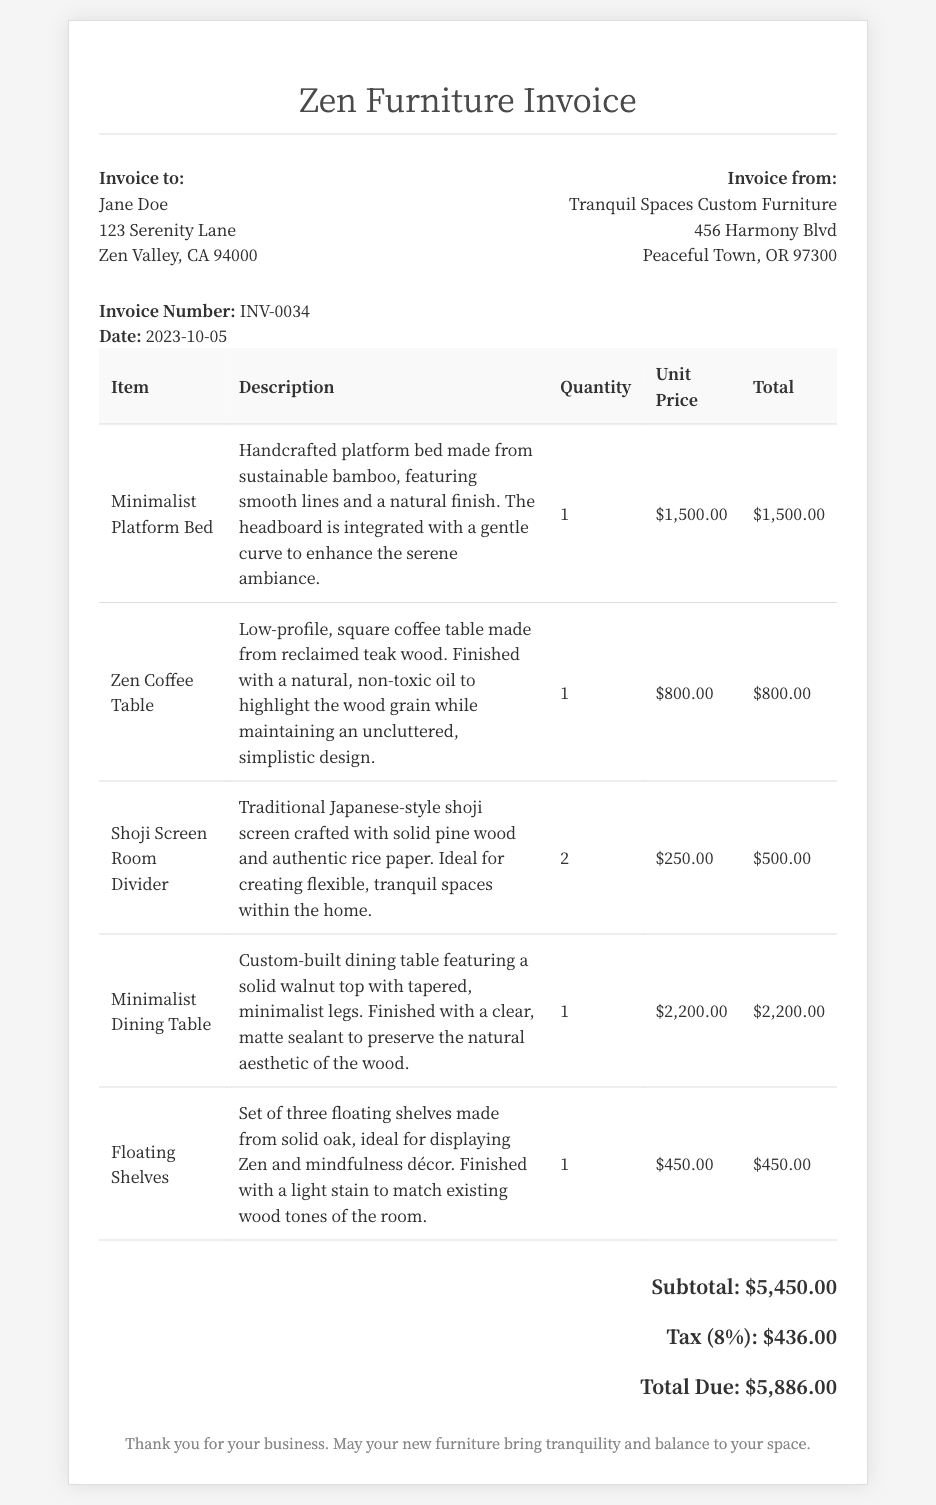What is the invoice number? The invoice number is listed in the document for reference.
Answer: INV-0034 Who is the invoice addressed to? The invoice includes the name of the recipient at the top.
Answer: Jane Doe What is the date of the invoice? The date of the invoice is provided in the document.
Answer: 2023-10-05 How many Shoji Screen Room Dividers were purchased? The quantity of Shoji Screen Room Dividers is specified in the item list.
Answer: 2 What is the total amount due? The total amount due is calculated at the bottom of the invoice.
Answer: $5,886.00 What type of wood is the Zen Coffee Table made from? The description of the Zen Coffee Table specifies its material.
Answer: Reclaimed teak wood What is the subtotal before tax? The subtotal is mentioned in the pricing section of the document.
Answer: $5,450.00 What is the tax rate applied to the invoice? The tax amount is given in the invoice, which allows us to deduce the tax rate.
Answer: 8% Which company issued the invoice? The issuing company is listed in the invoice header.
Answer: Tranquil Spaces Custom Furniture 